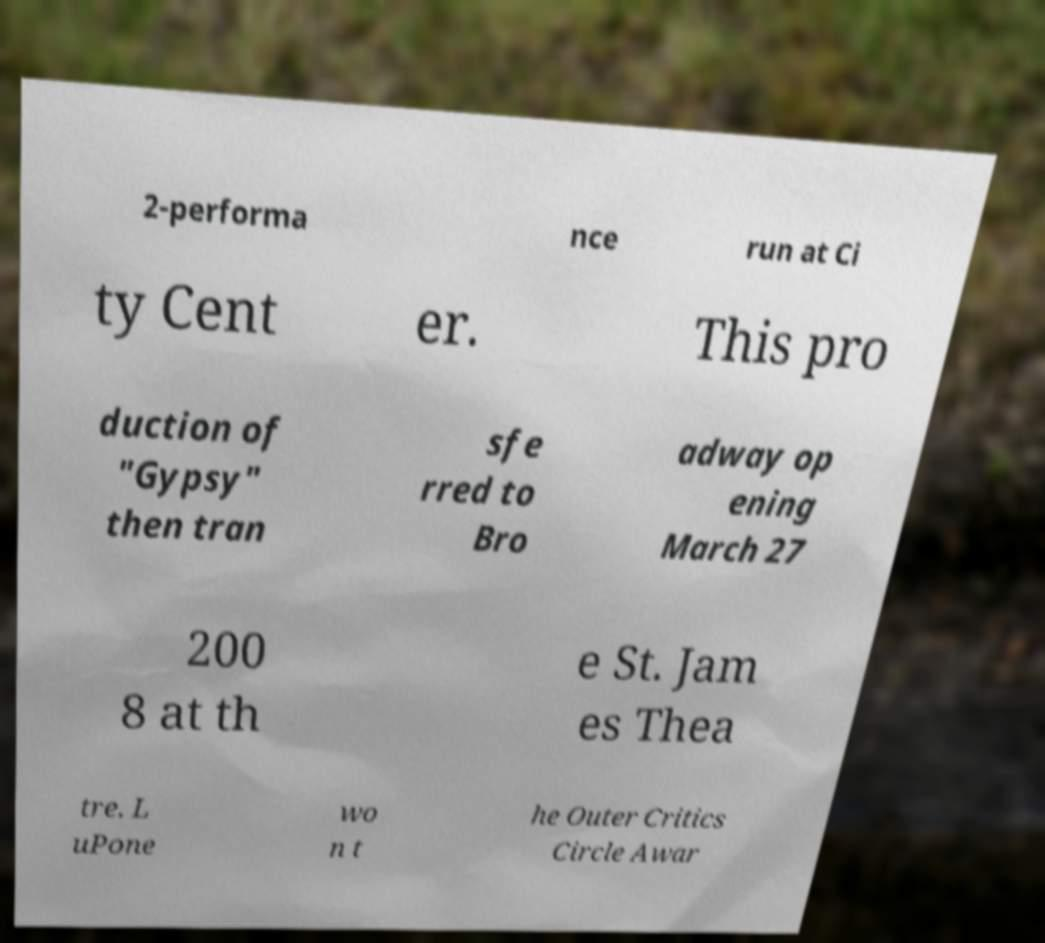There's text embedded in this image that I need extracted. Can you transcribe it verbatim? 2-performa nce run at Ci ty Cent er. This pro duction of "Gypsy" then tran sfe rred to Bro adway op ening March 27 200 8 at th e St. Jam es Thea tre. L uPone wo n t he Outer Critics Circle Awar 